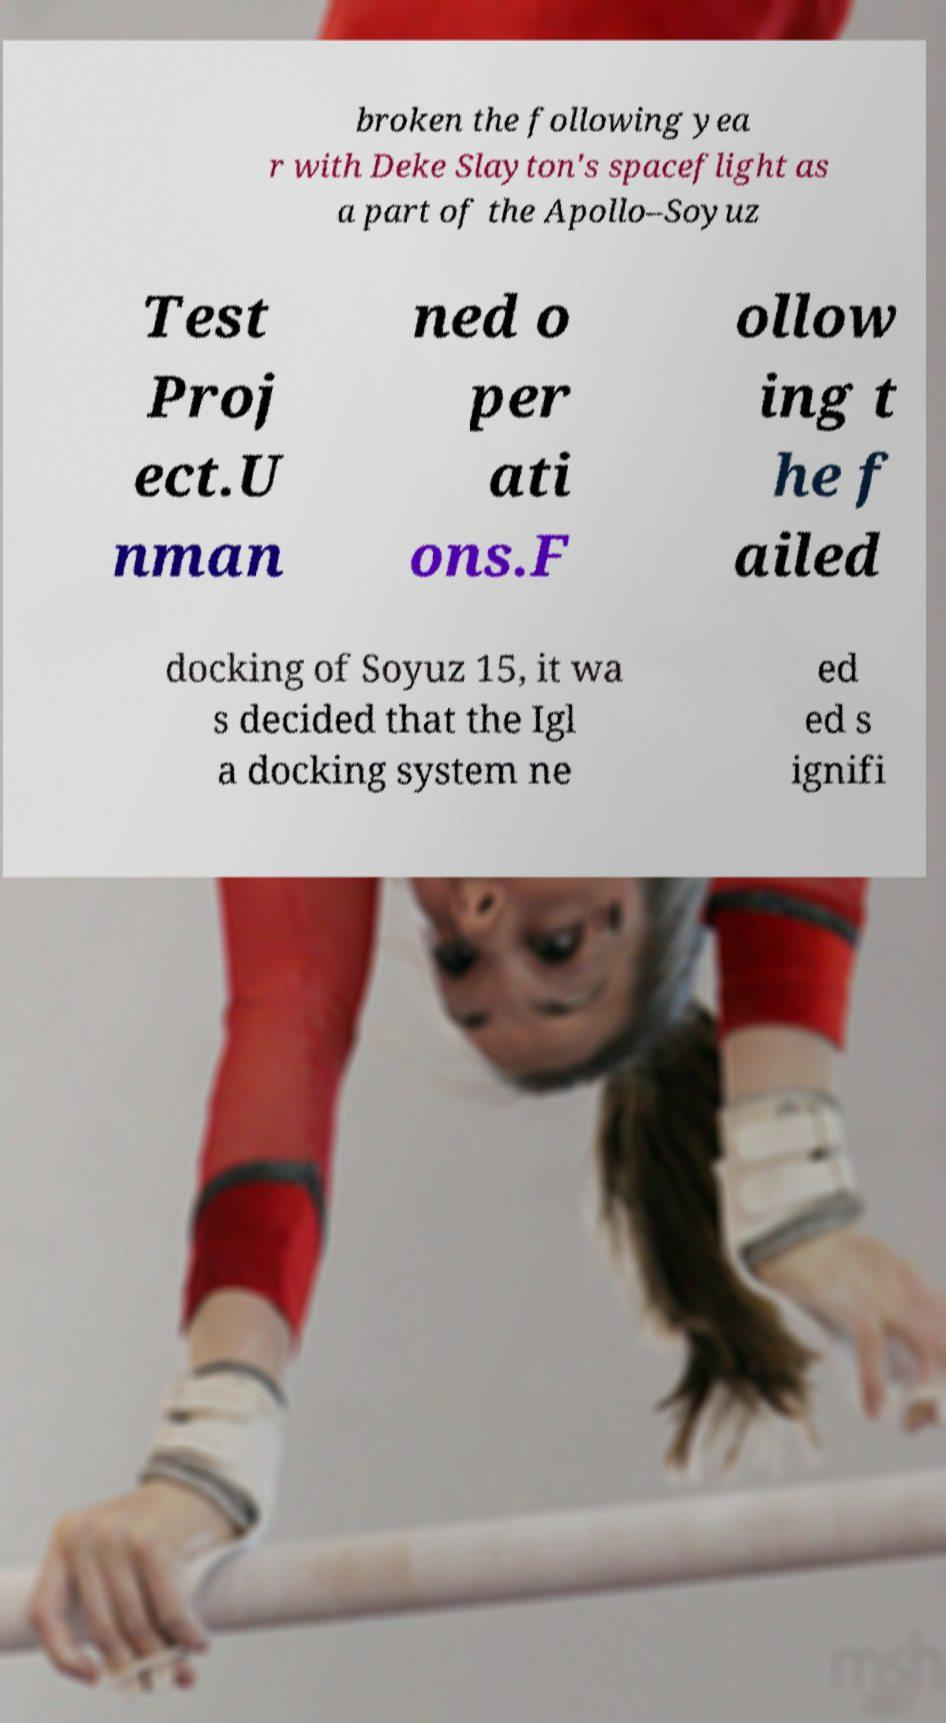Could you assist in decoding the text presented in this image and type it out clearly? broken the following yea r with Deke Slayton's spaceflight as a part of the Apollo–Soyuz Test Proj ect.U nman ned o per ati ons.F ollow ing t he f ailed docking of Soyuz 15, it wa s decided that the Igl a docking system ne ed ed s ignifi 